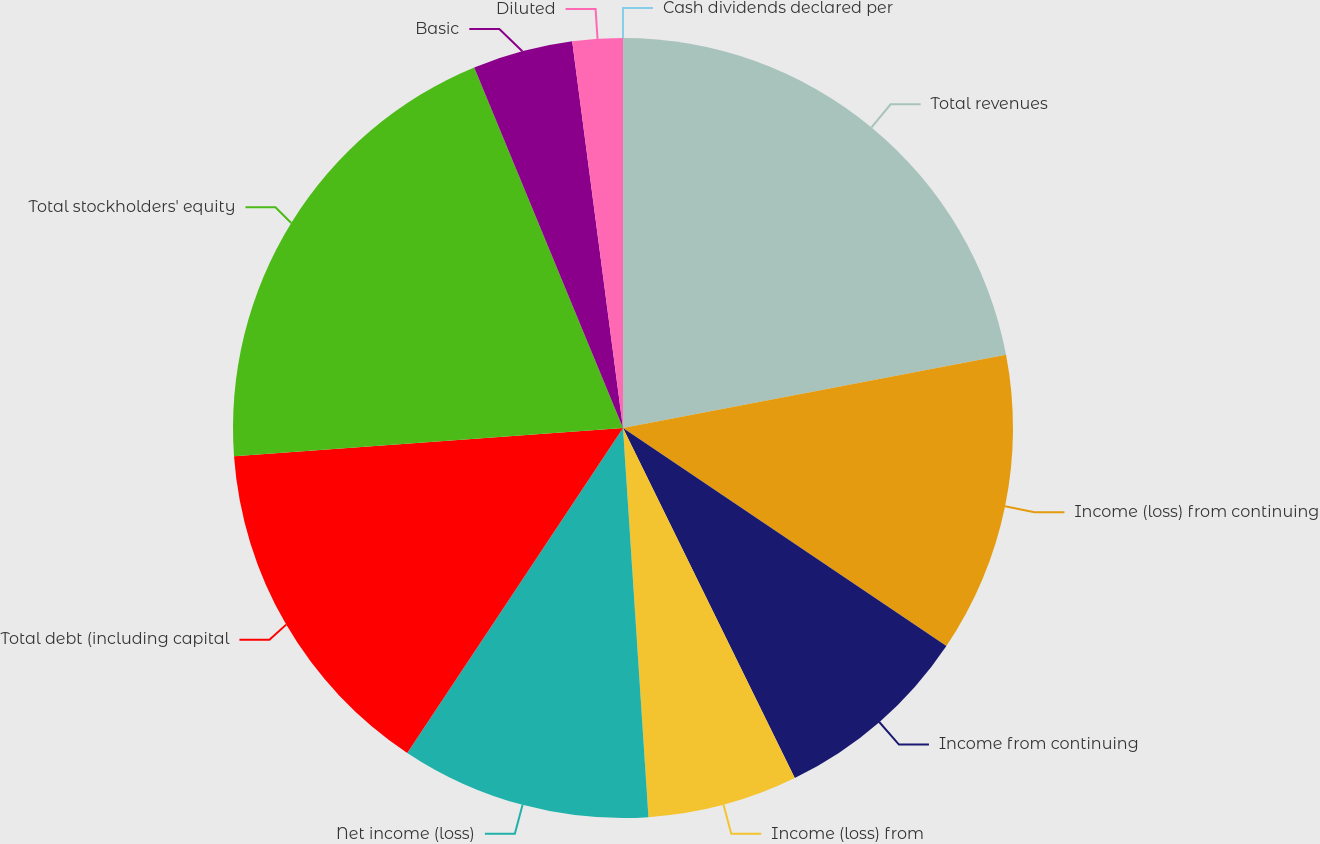Convert chart to OTSL. <chart><loc_0><loc_0><loc_500><loc_500><pie_chart><fcel>Total revenues<fcel>Income (loss) from continuing<fcel>Income from continuing<fcel>Income (loss) from<fcel>Net income (loss)<fcel>Total debt (including capital<fcel>Total stockholders' equity<fcel>Basic<fcel>Diluted<fcel>Cash dividends declared per<nl><fcel>21.99%<fcel>12.45%<fcel>8.3%<fcel>6.22%<fcel>10.37%<fcel>14.52%<fcel>19.92%<fcel>4.15%<fcel>2.08%<fcel>0.0%<nl></chart> 